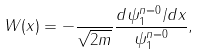<formula> <loc_0><loc_0><loc_500><loc_500>W ( x ) = - \frac { } { \sqrt { 2 m } } \frac { d \psi _ { 1 } ^ { n = 0 } / d x } { \psi _ { 1 } ^ { n = 0 } } ,</formula> 